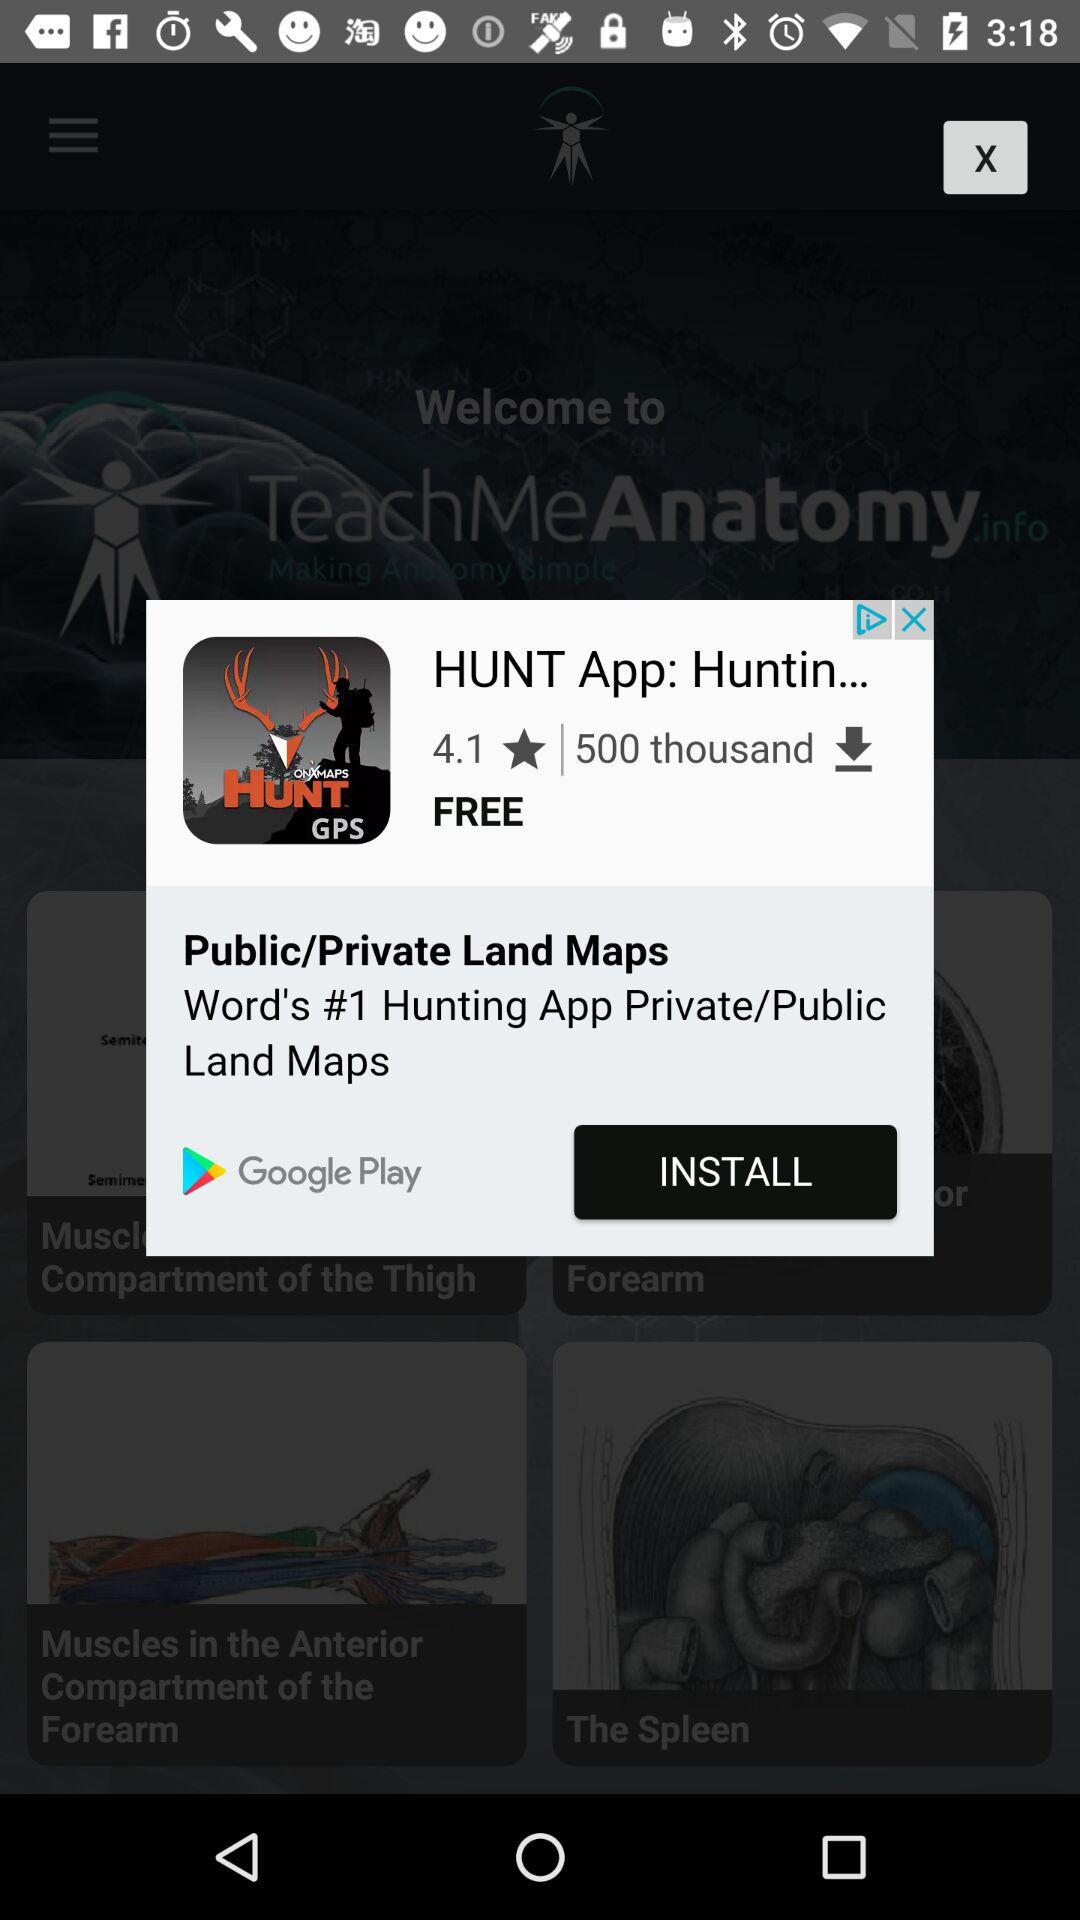What is the rating of the application? The rating of the application is 4.1. 